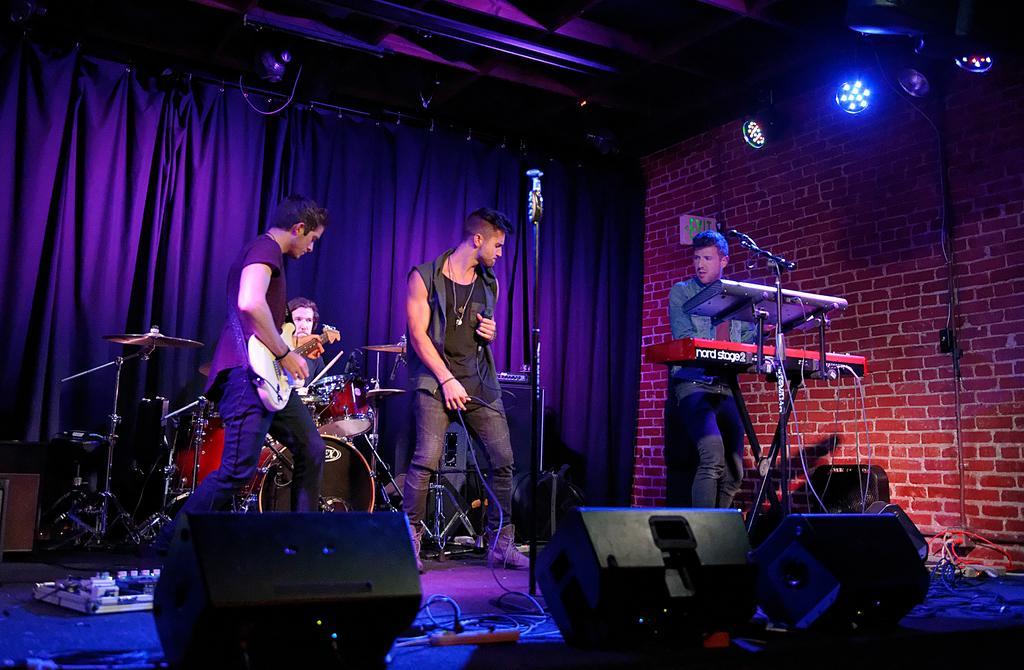Please provide a concise description of this image. There are three persons standing. Among them one person is playing guitar,another person is singing a song,and the other person is playing piano. This is a mike with the mike stand. I think these are the speakers and I can see a small plug box here where cables are connected. This is a kind of object which is white in color. I can see another person sitting and playing drums. This is a black curtain which is hanging through the hanger. These are the show lights which are attached to the wall. This is a red brick textured wall. 